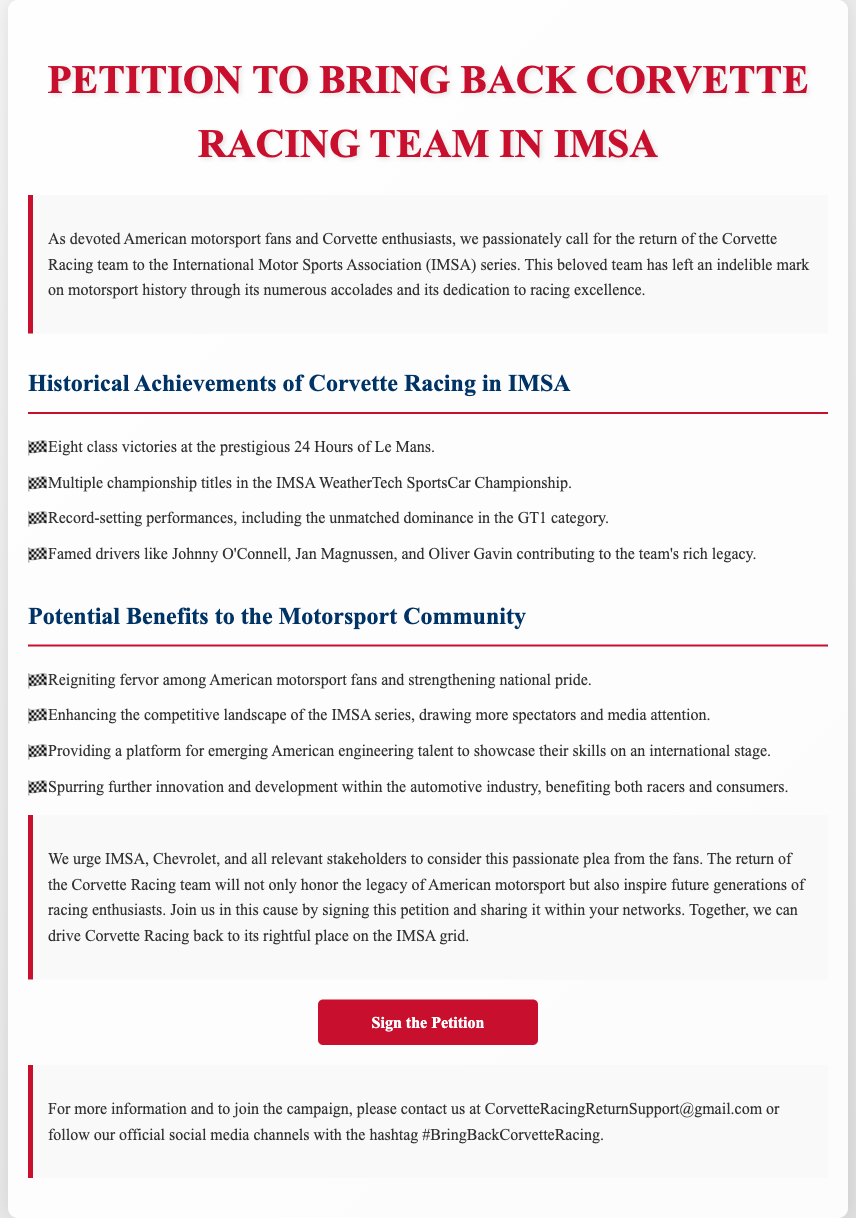What is the title of the petition? The title of the petition is stated at the top of the document.
Answer: Petition to Bring Back Corvette Racing Team in IMSA How many class victories at the 24 Hours of Le Mans does Corvette Racing have? The petition lists the number of class victories as part of Corvette Racing's historical achievements.
Answer: Eight class victories Name one famous driver associated with Corvette Racing. The document mentions several famed drivers in the achievements section.
Answer: Johnny O'Connell What is one potential benefit of bringing back Corvette Racing to the IMSA series? The document includes a section on potential benefits, highlighting several aspects of interest.
Answer: Enhancing the competitive landscape What email address is provided for more information about the petition? The contact information section of the document lists an email for inquiries.
Answer: CorvetteRacingReturnSupport@gmail.com Which color is used for the title text? The styling details highlight the color used for the title in the document.
Answer: #c8102e How are the achievements of Corvette Racing presented in the document? The document lists the achievements using unordered bullet points under a specific header.
Answer: Unordered bullet points What hashtag is suggested for social media promotion? The last paragraph mentions a hashtag for spreading the word about the petition.
Answer: #BringBackCorvetteRacing 